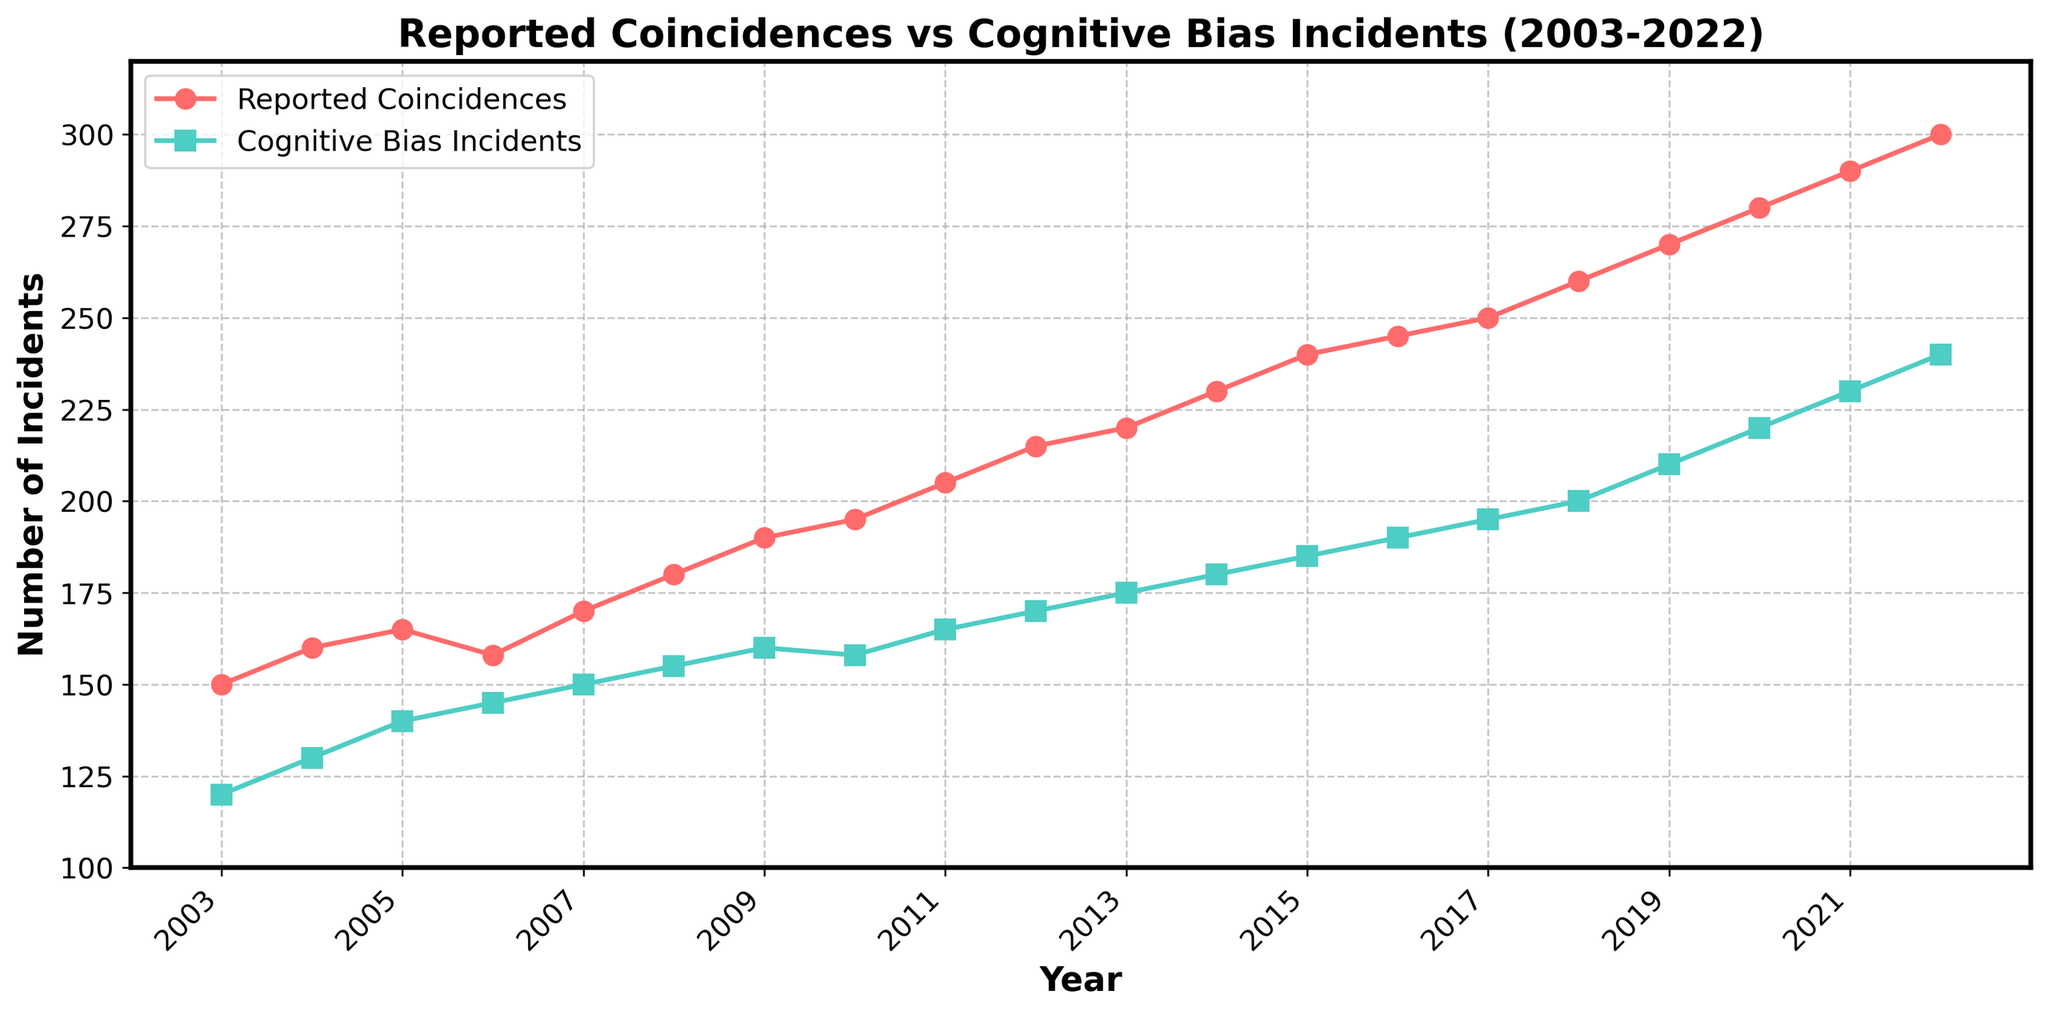What's the title of the figure? The title is displayed at the top of the figure and reads 'Reported Coincidences vs Cognitive Bias Incidents (2003-2022)'.
Answer: Reported Coincidences vs Cognitive Bias Incidents (2003-2022) What is the general trend of reported coincidences over the years? By observing the plot line labeled 'Reported Coincidences', it steadily increases from 150 in 2003 to 300 in 2022, indicating a general upward trend.
Answer: Upward trend Which year shows the highest number of cognitive bias incidents? The highest number of cognitive bias incidents is indicated at the end of the ‘Cognitive Bias Incidents’ plot line, with 240 in 2022.
Answer: 2022 What is the difference in the number of reported coincidences between 2010 and 2015? The value in 2010 for reported coincidences is 195, and in 2015 it is 240. The difference between these two years is 240 - 195 = 45.
Answer: 45 Are there any years when the numbers of reported coincidences and cognitive bias incidents are equal or very close? By examining the plot lines, no years show equal values, but 2010 has values that are very close: 195 (coincidences) and 158 (biases).
Answer: No, but 2010 has close values How do the cognitive bias incidents compare to reported coincidences in 2009? Cognitive bias incidents in 2009 are 160, while reported coincidences are 190. The number of reported coincidences is higher than cognitive bias incidents.
Answer: Reported coincidences are higher What is the average number of reported coincidences over the decade from 2013 to 2022? To find the average, sum all reported coincidences from 2013 to 2022 and then divide by the number of years. The sum is 220 + 230 + 240 + 245 + 250 + 260 + 270 + 280 + 290 + 300 = 2585. There are 10 years, so the average is 2585 / 10 = 258.5.
Answer: 258.5 What is the median number of cognitive bias incidents reported between 2014 and 2022? Organize the values from smallest to largest: 180, 185, 190, 195, 200, 210, 220, 230, 240. The median is the 5th value in this ordered list, which is 200.
Answer: 200 Which year shows the largest gap between reported coincidences and cognitive bias incidents? To identify the year with the largest gap, subtract the cognitive bias incidents from the reported coincidences for each year. The largest gap occurs in 2022 (300 - 240 = 60).
Answer: 2022 What’s the combined total of reported coincidences and cognitive bias incidents in 2020? The reported coincidences in 2020 are 280, and the cognitive bias incidents are 220. Combined total is 280 + 220 = 500.
Answer: 500 